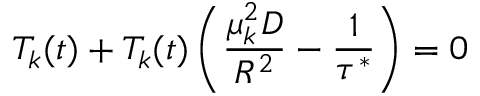<formula> <loc_0><loc_0><loc_500><loc_500>T _ { k } ( t ) + T _ { k } ( t ) \left ( \frac { \mu _ { k } ^ { 2 } D } { R ^ { 2 } } - \frac { 1 } { \tau ^ { * } } \right ) = 0</formula> 